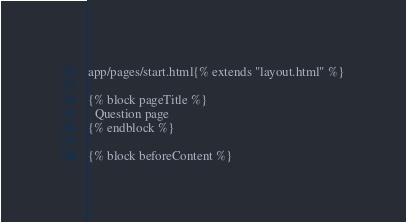<code> <loc_0><loc_0><loc_500><loc_500><_HTML_>app/pages/start.html{% extends "layout.html" %}

{% block pageTitle %}
  Question page
{% endblock %}

{% block beforeContent %}</code> 